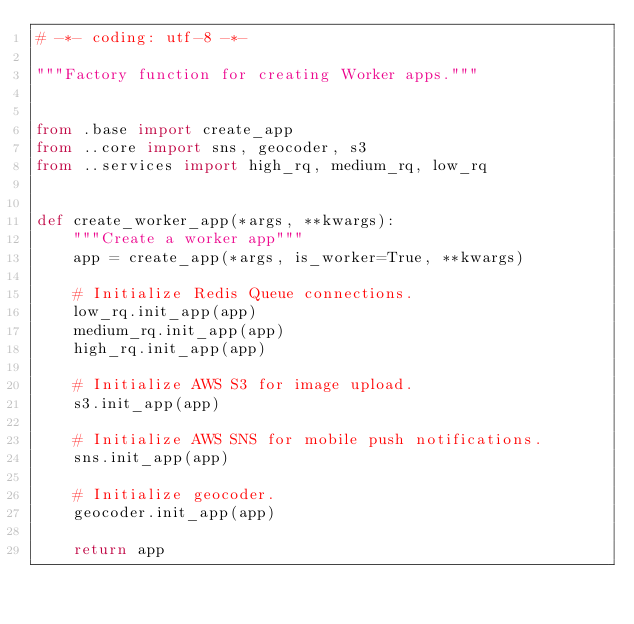<code> <loc_0><loc_0><loc_500><loc_500><_Python_># -*- coding: utf-8 -*-

"""Factory function for creating Worker apps."""


from .base import create_app
from ..core import sns, geocoder, s3
from ..services import high_rq, medium_rq, low_rq


def create_worker_app(*args, **kwargs):
    """Create a worker app"""
    app = create_app(*args, is_worker=True, **kwargs)

    # Initialize Redis Queue connections.
    low_rq.init_app(app)
    medium_rq.init_app(app)
    high_rq.init_app(app)

    # Initialize AWS S3 for image upload.
    s3.init_app(app)

    # Initialize AWS SNS for mobile push notifications.
    sns.init_app(app)

    # Initialize geocoder.
    geocoder.init_app(app)

    return app
</code> 